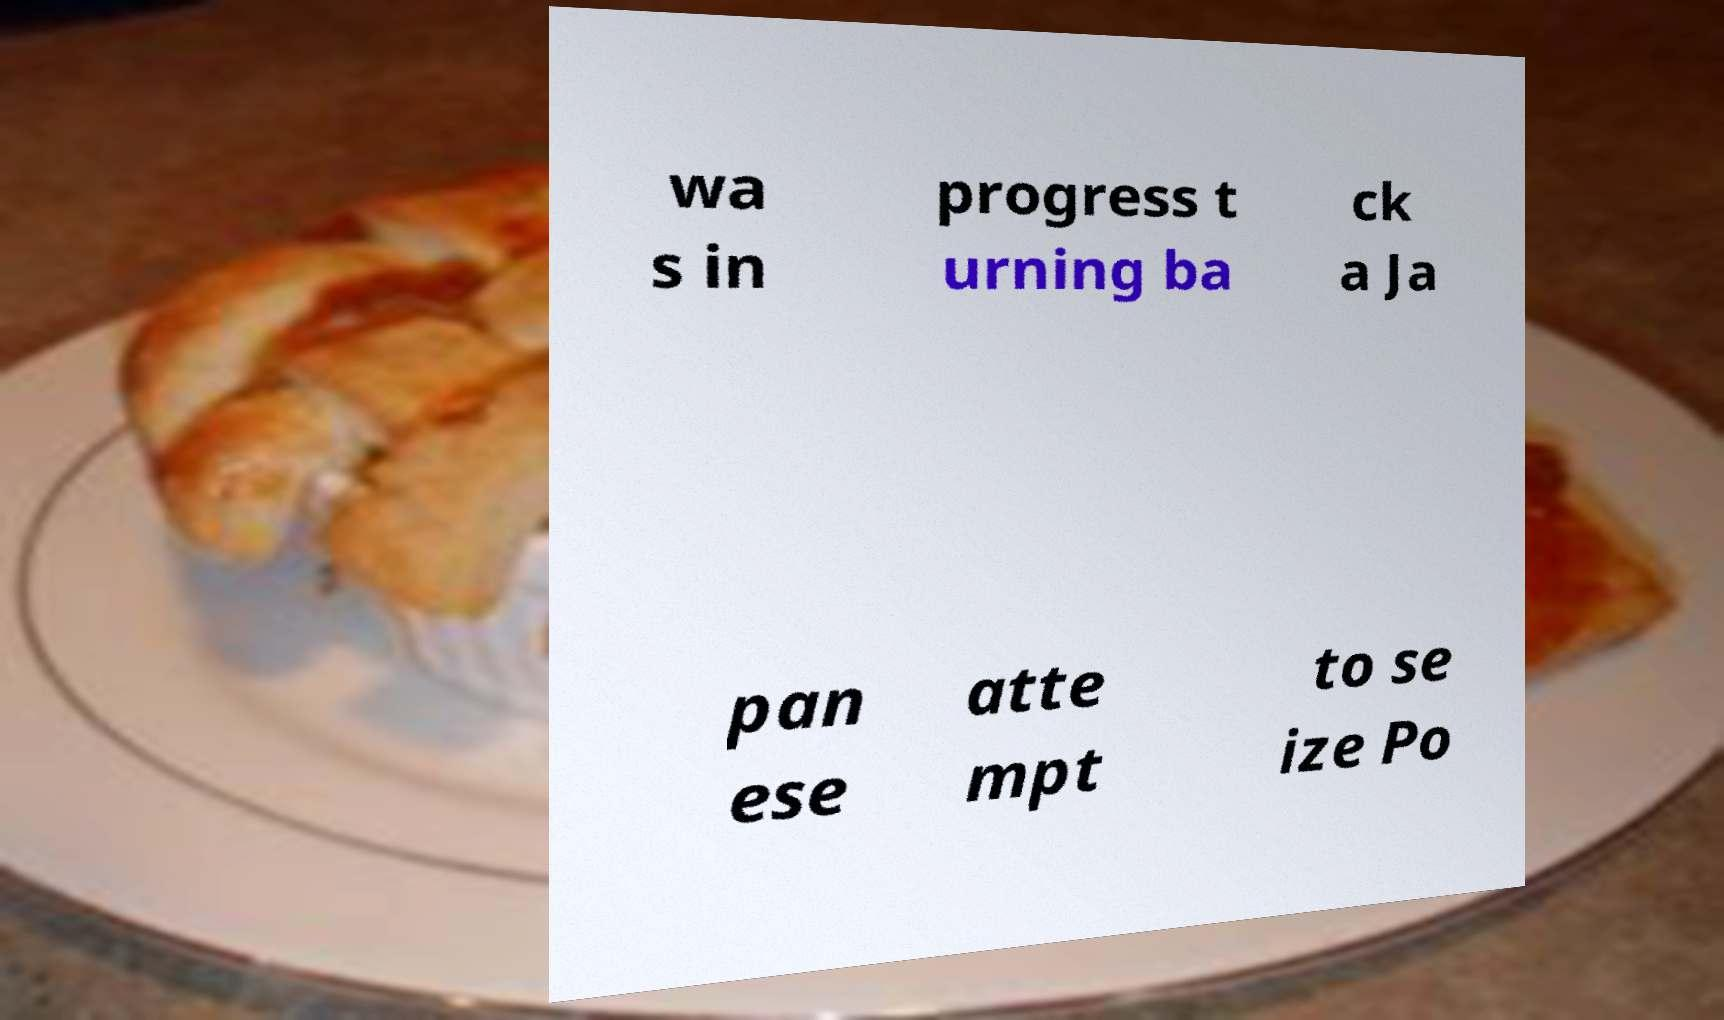Can you accurately transcribe the text from the provided image for me? wa s in progress t urning ba ck a Ja pan ese atte mpt to se ize Po 